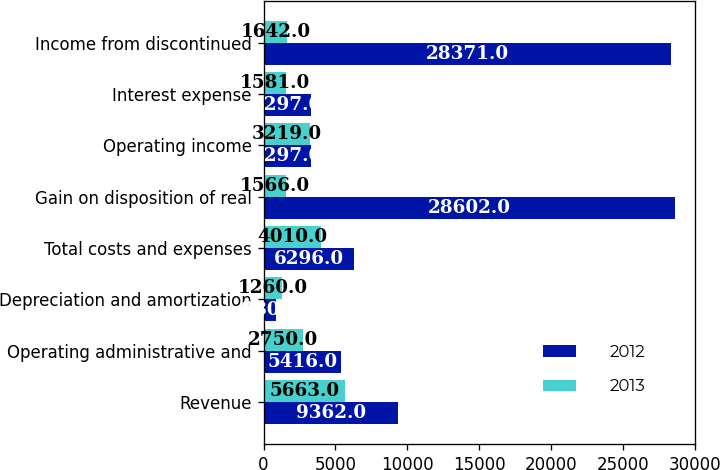<chart> <loc_0><loc_0><loc_500><loc_500><stacked_bar_chart><ecel><fcel>Revenue<fcel>Operating administrative and<fcel>Depreciation and amortization<fcel>Total costs and expenses<fcel>Gain on disposition of real<fcel>Operating income<fcel>Interest expense<fcel>Income from discontinued<nl><fcel>2012<fcel>9362<fcel>5416<fcel>880<fcel>6296<fcel>28602<fcel>3297<fcel>3297<fcel>28371<nl><fcel>2013<fcel>5663<fcel>2750<fcel>1260<fcel>4010<fcel>1566<fcel>3219<fcel>1581<fcel>1642<nl></chart> 